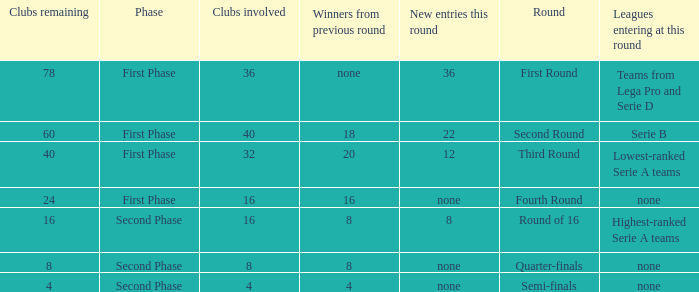When looking at new entries this round and seeing 8; what number in total is there for clubs remaining? 1.0. 